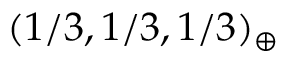Convert formula to latex. <formula><loc_0><loc_0><loc_500><loc_500>( 1 / 3 , 1 / 3 , 1 / 3 ) _ { \oplus }</formula> 